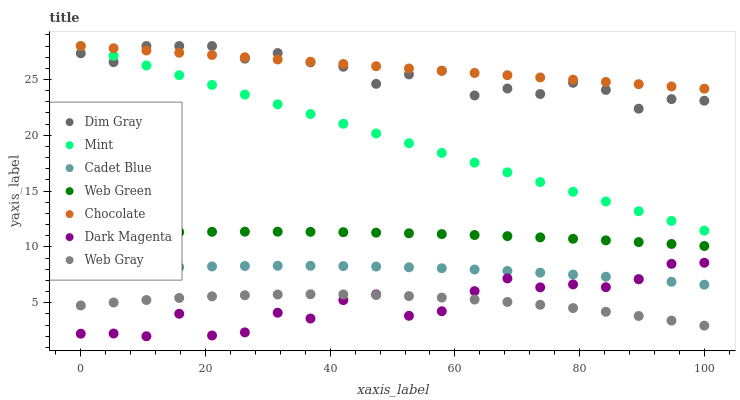Does Dark Magenta have the minimum area under the curve?
Answer yes or no. Yes. Does Chocolate have the maximum area under the curve?
Answer yes or no. Yes. Does Web Green have the minimum area under the curve?
Answer yes or no. No. Does Web Green have the maximum area under the curve?
Answer yes or no. No. Is Mint the smoothest?
Answer yes or no. Yes. Is Dark Magenta the roughest?
Answer yes or no. Yes. Is Web Green the smoothest?
Answer yes or no. No. Is Web Green the roughest?
Answer yes or no. No. Does Dark Magenta have the lowest value?
Answer yes or no. Yes. Does Web Green have the lowest value?
Answer yes or no. No. Does Mint have the highest value?
Answer yes or no. Yes. Does Dark Magenta have the highest value?
Answer yes or no. No. Is Web Green less than Mint?
Answer yes or no. Yes. Is Chocolate greater than Cadet Blue?
Answer yes or no. Yes. Does Dim Gray intersect Mint?
Answer yes or no. Yes. Is Dim Gray less than Mint?
Answer yes or no. No. Is Dim Gray greater than Mint?
Answer yes or no. No. Does Web Green intersect Mint?
Answer yes or no. No. 